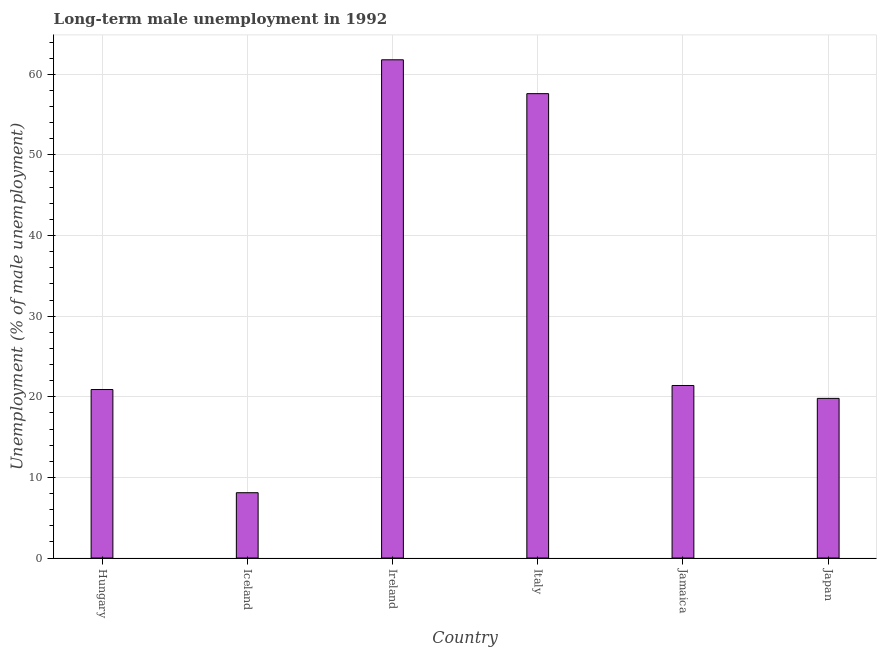Does the graph contain any zero values?
Offer a terse response. No. What is the title of the graph?
Keep it short and to the point. Long-term male unemployment in 1992. What is the label or title of the Y-axis?
Your answer should be very brief. Unemployment (% of male unemployment). What is the long-term male unemployment in Italy?
Make the answer very short. 57.6. Across all countries, what is the maximum long-term male unemployment?
Keep it short and to the point. 61.8. Across all countries, what is the minimum long-term male unemployment?
Offer a terse response. 8.1. In which country was the long-term male unemployment maximum?
Keep it short and to the point. Ireland. What is the sum of the long-term male unemployment?
Offer a very short reply. 189.6. What is the difference between the long-term male unemployment in Iceland and Italy?
Make the answer very short. -49.5. What is the average long-term male unemployment per country?
Make the answer very short. 31.6. What is the median long-term male unemployment?
Ensure brevity in your answer.  21.15. In how many countries, is the long-term male unemployment greater than 50 %?
Ensure brevity in your answer.  2. What is the ratio of the long-term male unemployment in Ireland to that in Italy?
Provide a short and direct response. 1.07. Is the long-term male unemployment in Jamaica less than that in Japan?
Your answer should be compact. No. Is the difference between the long-term male unemployment in Ireland and Japan greater than the difference between any two countries?
Your response must be concise. No. Is the sum of the long-term male unemployment in Hungary and Jamaica greater than the maximum long-term male unemployment across all countries?
Make the answer very short. No. What is the difference between the highest and the lowest long-term male unemployment?
Your answer should be compact. 53.7. Are all the bars in the graph horizontal?
Offer a very short reply. No. How many countries are there in the graph?
Ensure brevity in your answer.  6. What is the difference between two consecutive major ticks on the Y-axis?
Offer a terse response. 10. Are the values on the major ticks of Y-axis written in scientific E-notation?
Provide a succinct answer. No. What is the Unemployment (% of male unemployment) in Hungary?
Make the answer very short. 20.9. What is the Unemployment (% of male unemployment) in Iceland?
Make the answer very short. 8.1. What is the Unemployment (% of male unemployment) of Ireland?
Offer a very short reply. 61.8. What is the Unemployment (% of male unemployment) of Italy?
Your answer should be compact. 57.6. What is the Unemployment (% of male unemployment) of Jamaica?
Your response must be concise. 21.4. What is the Unemployment (% of male unemployment) in Japan?
Your answer should be very brief. 19.8. What is the difference between the Unemployment (% of male unemployment) in Hungary and Ireland?
Offer a very short reply. -40.9. What is the difference between the Unemployment (% of male unemployment) in Hungary and Italy?
Offer a terse response. -36.7. What is the difference between the Unemployment (% of male unemployment) in Iceland and Ireland?
Keep it short and to the point. -53.7. What is the difference between the Unemployment (% of male unemployment) in Iceland and Italy?
Provide a succinct answer. -49.5. What is the difference between the Unemployment (% of male unemployment) in Ireland and Jamaica?
Offer a terse response. 40.4. What is the difference between the Unemployment (% of male unemployment) in Ireland and Japan?
Provide a succinct answer. 42. What is the difference between the Unemployment (% of male unemployment) in Italy and Jamaica?
Your answer should be compact. 36.2. What is the difference between the Unemployment (% of male unemployment) in Italy and Japan?
Offer a very short reply. 37.8. What is the ratio of the Unemployment (% of male unemployment) in Hungary to that in Iceland?
Your answer should be very brief. 2.58. What is the ratio of the Unemployment (% of male unemployment) in Hungary to that in Ireland?
Keep it short and to the point. 0.34. What is the ratio of the Unemployment (% of male unemployment) in Hungary to that in Italy?
Provide a short and direct response. 0.36. What is the ratio of the Unemployment (% of male unemployment) in Hungary to that in Japan?
Give a very brief answer. 1.06. What is the ratio of the Unemployment (% of male unemployment) in Iceland to that in Ireland?
Provide a short and direct response. 0.13. What is the ratio of the Unemployment (% of male unemployment) in Iceland to that in Italy?
Ensure brevity in your answer.  0.14. What is the ratio of the Unemployment (% of male unemployment) in Iceland to that in Jamaica?
Offer a terse response. 0.38. What is the ratio of the Unemployment (% of male unemployment) in Iceland to that in Japan?
Your answer should be compact. 0.41. What is the ratio of the Unemployment (% of male unemployment) in Ireland to that in Italy?
Your response must be concise. 1.07. What is the ratio of the Unemployment (% of male unemployment) in Ireland to that in Jamaica?
Offer a terse response. 2.89. What is the ratio of the Unemployment (% of male unemployment) in Ireland to that in Japan?
Make the answer very short. 3.12. What is the ratio of the Unemployment (% of male unemployment) in Italy to that in Jamaica?
Provide a succinct answer. 2.69. What is the ratio of the Unemployment (% of male unemployment) in Italy to that in Japan?
Offer a terse response. 2.91. What is the ratio of the Unemployment (% of male unemployment) in Jamaica to that in Japan?
Your answer should be very brief. 1.08. 